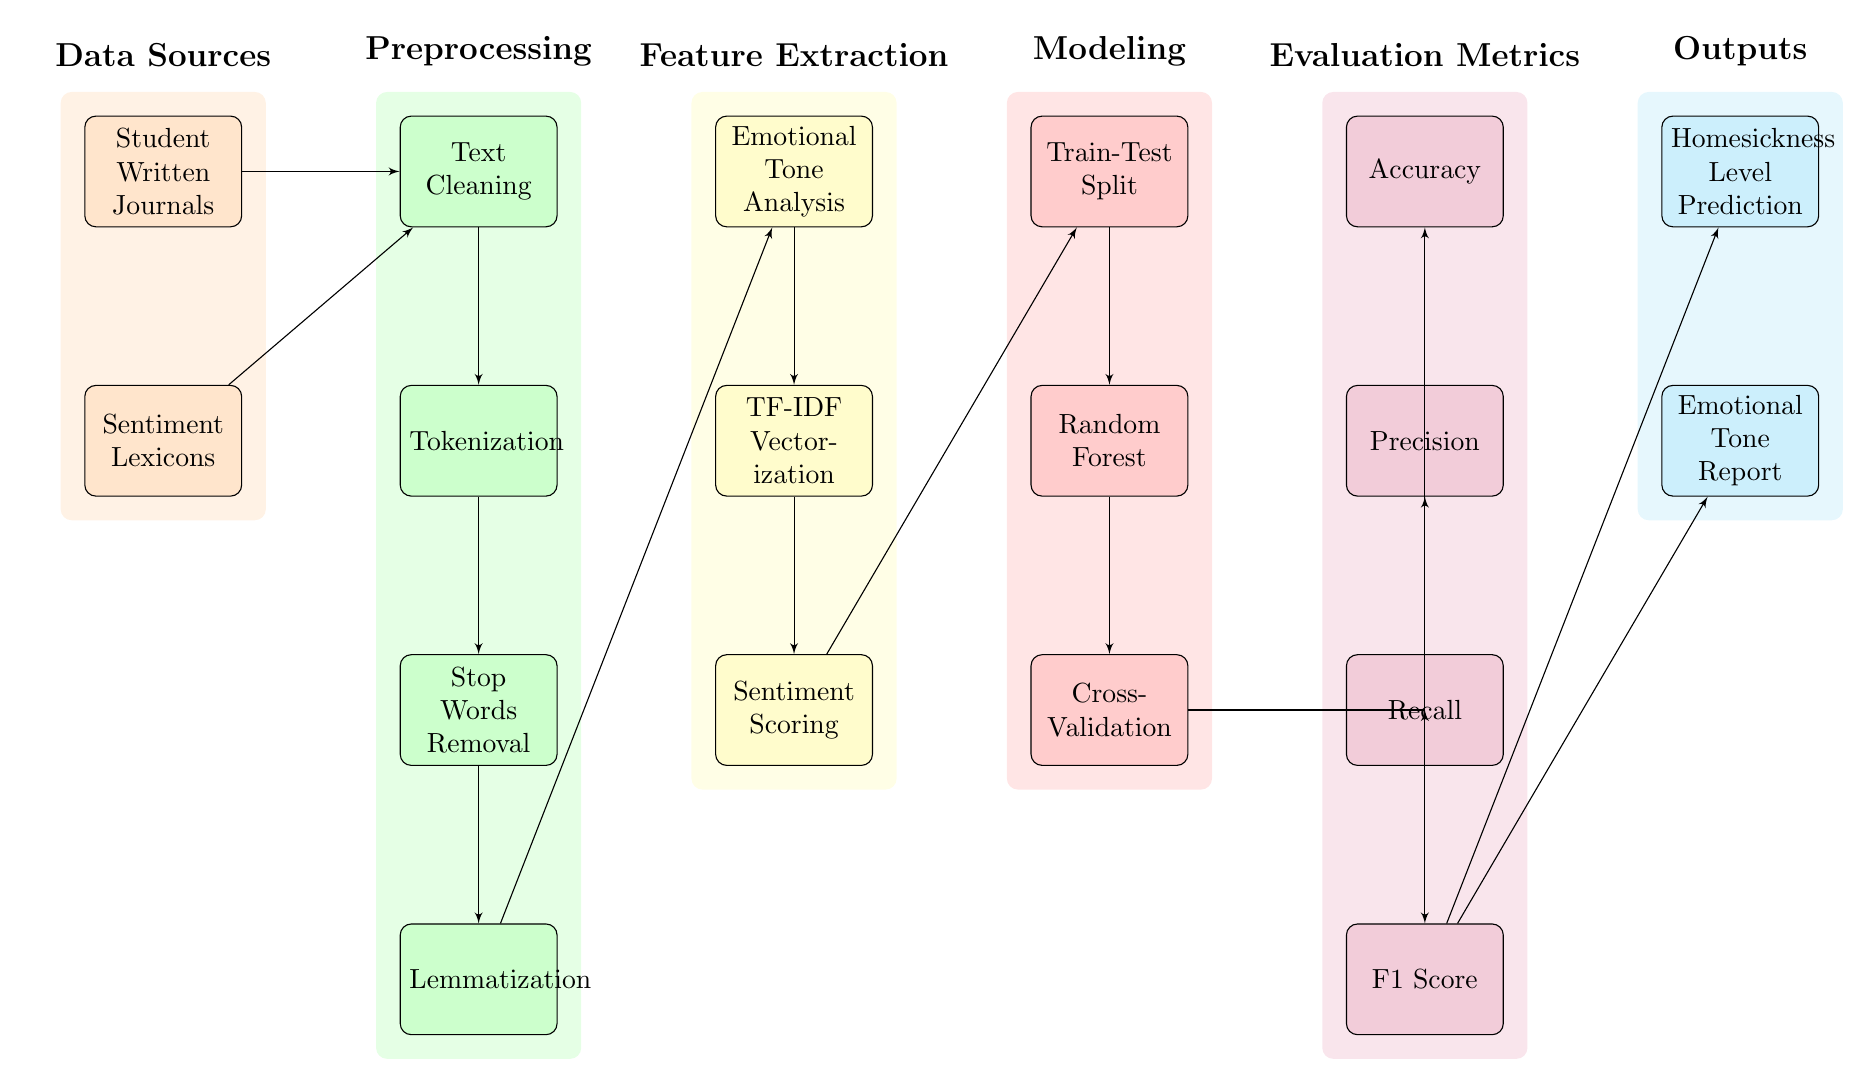what are the data sources used in this diagram? The diagram has two data sources labeled as "Student Written Journals" and "Sentiment Lexicons". These sources are depicted in orange blocks at the top left of the diagram.
Answer: Student Written Journals, Sentiment Lexicons how many preprocessing steps are there in the diagram? The diagram lists four preprocessing steps which are "Text Cleaning", "Tokenization", "Stop Words Removal", and "Lemmatization". They are represented in green blocks. Counting these gives a total of four steps.
Answer: 4 which block leads to the Emotional Tone Analysis? The block that directly leads to the "Emotional Tone Analysis" is "Lemmatization", which is positioned just above it in the flow. This shows that lemmatization is a prerequisite step for tone analysis.
Answer: Lemmatization what evaluation metrics are used in the diagram? The diagram outlines four evaluation metrics: "Accuracy", "Precision", "Recall", and "F1 Score". These metrics are arranged in purple blocks beneath the modeling section.
Answer: Accuracy, Precision, Recall, F1 Score which modeling technique is used after the Train-Test Split? After the "Train-Test Split", the modeling technique used is "Random Forest", indicated as the next step down in a red block.
Answer: Random Forest what are the outputs generated from the F1 Score? The outputs generated from the "F1 Score" are "Homesickness Level Prediction" and "Emotional Tone Report", shown as the final two blocks in cyan on the right side of the diagram.
Answer: Homesickness Level Prediction, Emotional Tone Report how many blocks are in the Feature Extraction category? Under the Feature Extraction category, there are three blocks: "Emotional Tone Analysis", "TF-IDF Vectorization", and "Sentiment Scoring". Counting these gives a total of three blocks.
Answer: 3 which block receives inputs from both the Emotional Tone Analysis and TF-IDF Vectorization? The "Sentiment Scoring" block receives inputs from both "Emotional Tone Analysis" and "TF-IDF Vectorization", as indicated by the arrows connecting them to this block.
Answer: Sentiment Scoring what is the last step before obtaining the predictions? The last step before obtaining the predictions is "F1 Score", which leads to the outputs. It is the step before "Homesickness Level Prediction" and "Emotional Tone Report".
Answer: F1 Score 